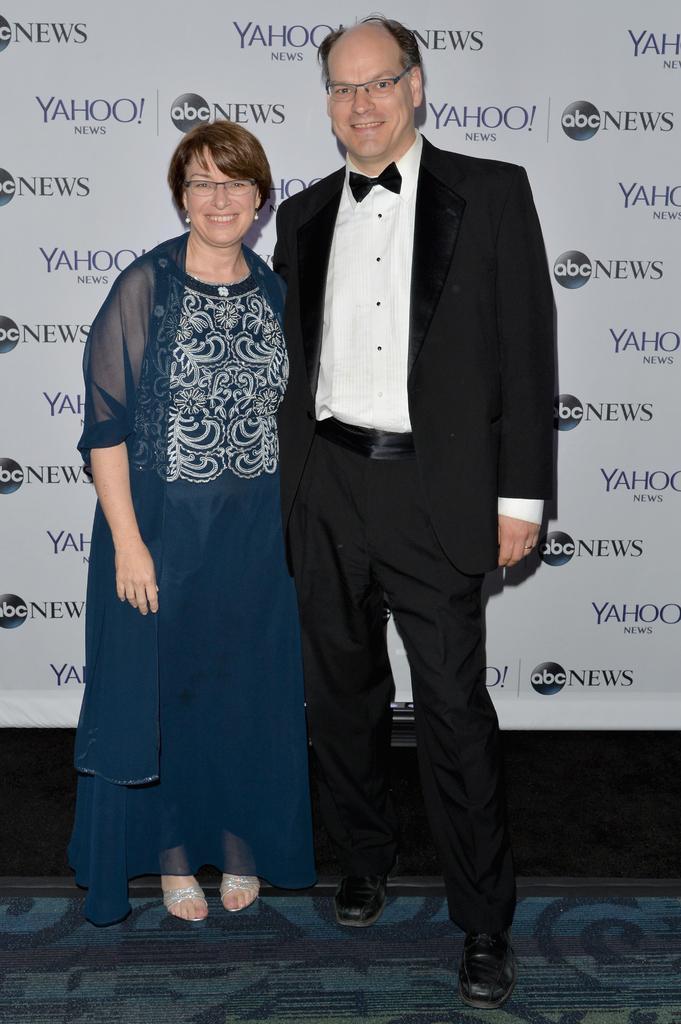How would you summarize this image in a sentence or two? In this picture we can see a man and a woman standing and smiling here, this man wore a suit, in the background we can see logos. 